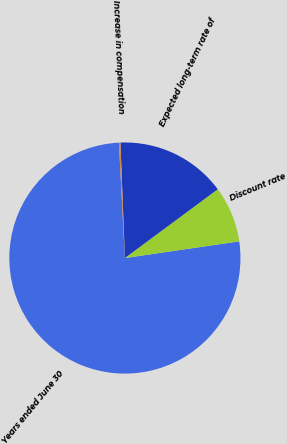Convert chart. <chart><loc_0><loc_0><loc_500><loc_500><pie_chart><fcel>Years ended June 30<fcel>Discount rate<fcel>Expected long-term rate of<fcel>Increase in compensation<nl><fcel>76.49%<fcel>7.84%<fcel>15.47%<fcel>0.21%<nl></chart> 